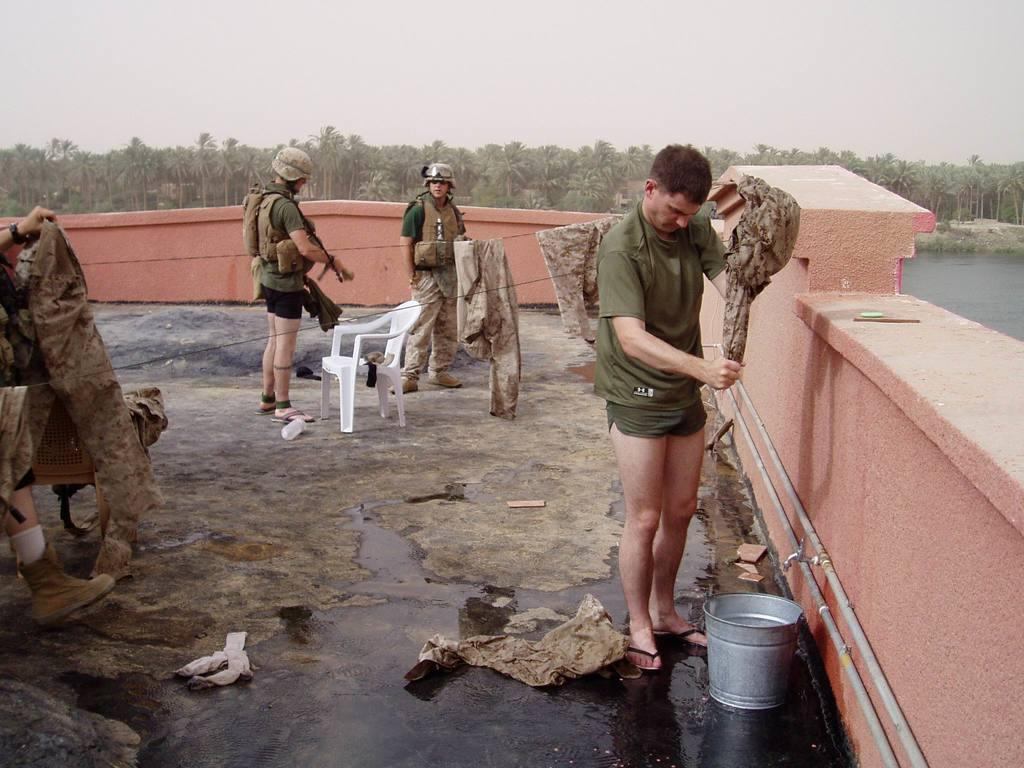How many men are present in the image? There are three men standing in the image. What is one of the men doing in the image? One of the men is washing clothes in the image. What piece of furniture can be seen in the image? There is a chair in the image. What type of natural vegetation is visible in the image? There are trees visible in the image. What type of water feature is present in the image? There is a canal in the image. What type of stew is being prepared by the men in the image? There is no indication in the image that the men are preparing any stew. What type of straw is being used by the men in the image? There is no straw present in the image. 